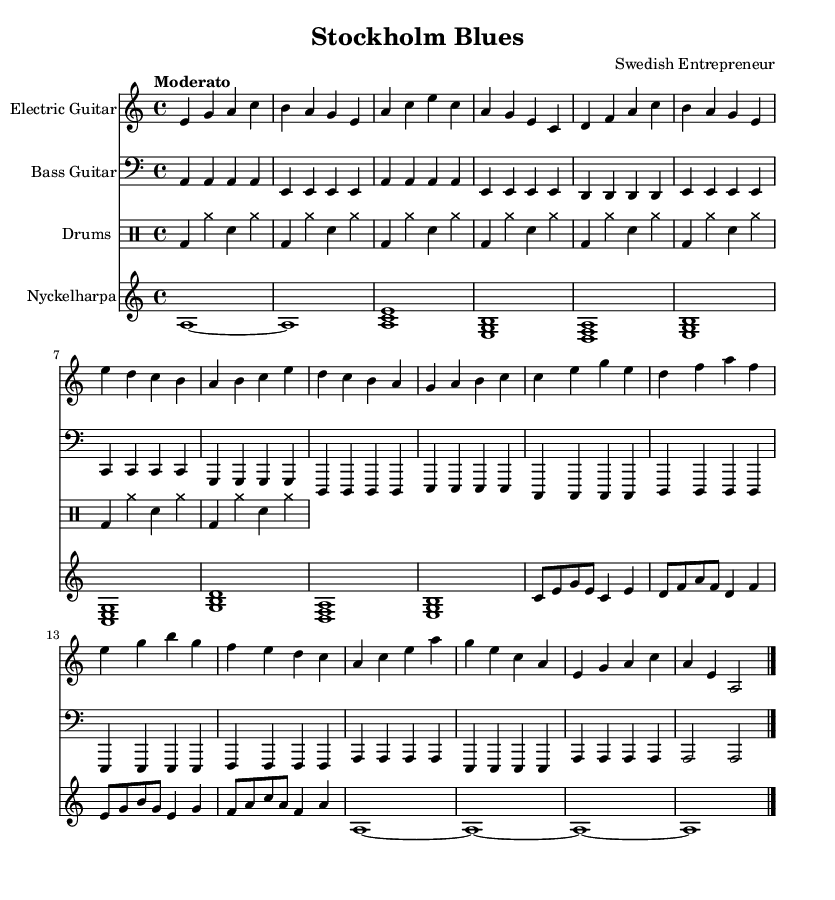What is the key signature of this music? The key signature is indicated by the presence of one flat, which is B flat, showing that the key is A minor.
Answer: A minor What is the time signature of this music? The time signature is indicated by the numbers at the beginning of the score, showing four beats in each measure.
Answer: 4/4 What is the tempo marking for this piece? The tempo marking is indicated at the beginning of the score with the term "Moderato", which suggests a moderate speed.
Answer: Moderato How many distinct sections are present in the music? By examining the structure, we can identify an Intro, Verse, Chorus, Bridge, and Outro, totaling five distinct sections.
Answer: 5 What instruments are included in this composition? The music lists the Electric Guitar, Bass Guitar, Drums, and Nyckelharpa as the instruments in the score.
Answer: Electric Guitar, Bass Guitar, Drums, Nyckelharpa What is the primary chord used in the Chorus section? By analyzing the notes in the Chorus (e d c b a b c e), the primary chord is built around the tonic, which is the E major chord.
Answer: E major What style is this music a fusion of? The notation suggests elements of modern electric blues and incorporates characteristics of Swedish folk music through the use of the Nyckelharpa.
Answer: Modern electric blues fusion with Swedish folk influences 